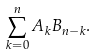Convert formula to latex. <formula><loc_0><loc_0><loc_500><loc_500>\sum _ { k = 0 } ^ { n } A _ { k } B _ { n - k } .</formula> 